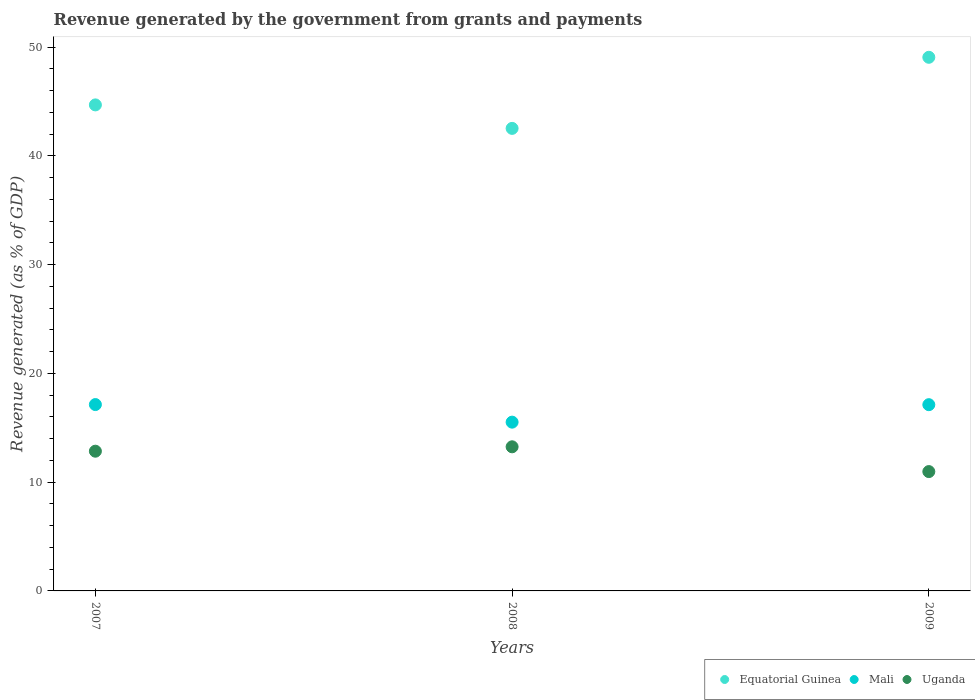What is the revenue generated by the government in Mali in 2007?
Offer a terse response. 17.14. Across all years, what is the maximum revenue generated by the government in Equatorial Guinea?
Provide a short and direct response. 49.07. Across all years, what is the minimum revenue generated by the government in Mali?
Give a very brief answer. 15.52. In which year was the revenue generated by the government in Uganda minimum?
Provide a short and direct response. 2009. What is the total revenue generated by the government in Mali in the graph?
Ensure brevity in your answer.  49.79. What is the difference between the revenue generated by the government in Mali in 2007 and that in 2008?
Your answer should be very brief. 1.62. What is the difference between the revenue generated by the government in Mali in 2009 and the revenue generated by the government in Equatorial Guinea in 2008?
Make the answer very short. -25.41. What is the average revenue generated by the government in Equatorial Guinea per year?
Keep it short and to the point. 45.44. In the year 2007, what is the difference between the revenue generated by the government in Uganda and revenue generated by the government in Equatorial Guinea?
Make the answer very short. -31.85. What is the ratio of the revenue generated by the government in Mali in 2007 to that in 2009?
Provide a succinct answer. 1. Is the difference between the revenue generated by the government in Uganda in 2008 and 2009 greater than the difference between the revenue generated by the government in Equatorial Guinea in 2008 and 2009?
Give a very brief answer. Yes. What is the difference between the highest and the second highest revenue generated by the government in Uganda?
Make the answer very short. 0.4. What is the difference between the highest and the lowest revenue generated by the government in Uganda?
Make the answer very short. 2.28. In how many years, is the revenue generated by the government in Equatorial Guinea greater than the average revenue generated by the government in Equatorial Guinea taken over all years?
Your answer should be very brief. 1. Is the sum of the revenue generated by the government in Uganda in 2008 and 2009 greater than the maximum revenue generated by the government in Mali across all years?
Make the answer very short. Yes. Is the revenue generated by the government in Mali strictly greater than the revenue generated by the government in Uganda over the years?
Your answer should be compact. Yes. How many dotlines are there?
Give a very brief answer. 3. Where does the legend appear in the graph?
Your answer should be very brief. Bottom right. How are the legend labels stacked?
Offer a terse response. Horizontal. What is the title of the graph?
Offer a terse response. Revenue generated by the government from grants and payments. What is the label or title of the X-axis?
Offer a terse response. Years. What is the label or title of the Y-axis?
Your answer should be compact. Revenue generated (as % of GDP). What is the Revenue generated (as % of GDP) of Equatorial Guinea in 2007?
Provide a short and direct response. 44.7. What is the Revenue generated (as % of GDP) in Mali in 2007?
Your response must be concise. 17.14. What is the Revenue generated (as % of GDP) of Uganda in 2007?
Give a very brief answer. 12.85. What is the Revenue generated (as % of GDP) in Equatorial Guinea in 2008?
Your response must be concise. 42.54. What is the Revenue generated (as % of GDP) of Mali in 2008?
Offer a very short reply. 15.52. What is the Revenue generated (as % of GDP) of Uganda in 2008?
Offer a very short reply. 13.25. What is the Revenue generated (as % of GDP) in Equatorial Guinea in 2009?
Offer a very short reply. 49.07. What is the Revenue generated (as % of GDP) of Mali in 2009?
Give a very brief answer. 17.13. What is the Revenue generated (as % of GDP) in Uganda in 2009?
Provide a short and direct response. 10.97. Across all years, what is the maximum Revenue generated (as % of GDP) of Equatorial Guinea?
Ensure brevity in your answer.  49.07. Across all years, what is the maximum Revenue generated (as % of GDP) in Mali?
Give a very brief answer. 17.14. Across all years, what is the maximum Revenue generated (as % of GDP) in Uganda?
Offer a very short reply. 13.25. Across all years, what is the minimum Revenue generated (as % of GDP) of Equatorial Guinea?
Your answer should be compact. 42.54. Across all years, what is the minimum Revenue generated (as % of GDP) of Mali?
Give a very brief answer. 15.52. Across all years, what is the minimum Revenue generated (as % of GDP) of Uganda?
Give a very brief answer. 10.97. What is the total Revenue generated (as % of GDP) in Equatorial Guinea in the graph?
Your response must be concise. 136.31. What is the total Revenue generated (as % of GDP) in Mali in the graph?
Your answer should be very brief. 49.79. What is the total Revenue generated (as % of GDP) in Uganda in the graph?
Your response must be concise. 37.08. What is the difference between the Revenue generated (as % of GDP) of Equatorial Guinea in 2007 and that in 2008?
Make the answer very short. 2.16. What is the difference between the Revenue generated (as % of GDP) in Mali in 2007 and that in 2008?
Make the answer very short. 1.62. What is the difference between the Revenue generated (as % of GDP) in Uganda in 2007 and that in 2008?
Ensure brevity in your answer.  -0.4. What is the difference between the Revenue generated (as % of GDP) in Equatorial Guinea in 2007 and that in 2009?
Offer a terse response. -4.38. What is the difference between the Revenue generated (as % of GDP) in Mali in 2007 and that in 2009?
Your response must be concise. 0.01. What is the difference between the Revenue generated (as % of GDP) of Uganda in 2007 and that in 2009?
Your answer should be very brief. 1.88. What is the difference between the Revenue generated (as % of GDP) of Equatorial Guinea in 2008 and that in 2009?
Offer a very short reply. -6.54. What is the difference between the Revenue generated (as % of GDP) in Mali in 2008 and that in 2009?
Your response must be concise. -1.61. What is the difference between the Revenue generated (as % of GDP) of Uganda in 2008 and that in 2009?
Provide a succinct answer. 2.28. What is the difference between the Revenue generated (as % of GDP) of Equatorial Guinea in 2007 and the Revenue generated (as % of GDP) of Mali in 2008?
Offer a terse response. 29.18. What is the difference between the Revenue generated (as % of GDP) of Equatorial Guinea in 2007 and the Revenue generated (as % of GDP) of Uganda in 2008?
Make the answer very short. 31.44. What is the difference between the Revenue generated (as % of GDP) in Mali in 2007 and the Revenue generated (as % of GDP) in Uganda in 2008?
Ensure brevity in your answer.  3.88. What is the difference between the Revenue generated (as % of GDP) of Equatorial Guinea in 2007 and the Revenue generated (as % of GDP) of Mali in 2009?
Your answer should be very brief. 27.57. What is the difference between the Revenue generated (as % of GDP) of Equatorial Guinea in 2007 and the Revenue generated (as % of GDP) of Uganda in 2009?
Give a very brief answer. 33.72. What is the difference between the Revenue generated (as % of GDP) of Mali in 2007 and the Revenue generated (as % of GDP) of Uganda in 2009?
Make the answer very short. 6.16. What is the difference between the Revenue generated (as % of GDP) in Equatorial Guinea in 2008 and the Revenue generated (as % of GDP) in Mali in 2009?
Ensure brevity in your answer.  25.41. What is the difference between the Revenue generated (as % of GDP) of Equatorial Guinea in 2008 and the Revenue generated (as % of GDP) of Uganda in 2009?
Give a very brief answer. 31.56. What is the difference between the Revenue generated (as % of GDP) in Mali in 2008 and the Revenue generated (as % of GDP) in Uganda in 2009?
Your answer should be compact. 4.55. What is the average Revenue generated (as % of GDP) of Equatorial Guinea per year?
Your answer should be compact. 45.44. What is the average Revenue generated (as % of GDP) of Mali per year?
Make the answer very short. 16.6. What is the average Revenue generated (as % of GDP) in Uganda per year?
Provide a short and direct response. 12.36. In the year 2007, what is the difference between the Revenue generated (as % of GDP) in Equatorial Guinea and Revenue generated (as % of GDP) in Mali?
Your response must be concise. 27.56. In the year 2007, what is the difference between the Revenue generated (as % of GDP) of Equatorial Guinea and Revenue generated (as % of GDP) of Uganda?
Your answer should be very brief. 31.85. In the year 2007, what is the difference between the Revenue generated (as % of GDP) in Mali and Revenue generated (as % of GDP) in Uganda?
Ensure brevity in your answer.  4.29. In the year 2008, what is the difference between the Revenue generated (as % of GDP) of Equatorial Guinea and Revenue generated (as % of GDP) of Mali?
Offer a very short reply. 27.02. In the year 2008, what is the difference between the Revenue generated (as % of GDP) in Equatorial Guinea and Revenue generated (as % of GDP) in Uganda?
Provide a succinct answer. 29.28. In the year 2008, what is the difference between the Revenue generated (as % of GDP) of Mali and Revenue generated (as % of GDP) of Uganda?
Make the answer very short. 2.27. In the year 2009, what is the difference between the Revenue generated (as % of GDP) of Equatorial Guinea and Revenue generated (as % of GDP) of Mali?
Provide a succinct answer. 31.95. In the year 2009, what is the difference between the Revenue generated (as % of GDP) in Equatorial Guinea and Revenue generated (as % of GDP) in Uganda?
Keep it short and to the point. 38.1. In the year 2009, what is the difference between the Revenue generated (as % of GDP) in Mali and Revenue generated (as % of GDP) in Uganda?
Make the answer very short. 6.15. What is the ratio of the Revenue generated (as % of GDP) in Equatorial Guinea in 2007 to that in 2008?
Ensure brevity in your answer.  1.05. What is the ratio of the Revenue generated (as % of GDP) of Mali in 2007 to that in 2008?
Your answer should be very brief. 1.1. What is the ratio of the Revenue generated (as % of GDP) of Uganda in 2007 to that in 2008?
Offer a very short reply. 0.97. What is the ratio of the Revenue generated (as % of GDP) in Equatorial Guinea in 2007 to that in 2009?
Your response must be concise. 0.91. What is the ratio of the Revenue generated (as % of GDP) of Uganda in 2007 to that in 2009?
Your answer should be very brief. 1.17. What is the ratio of the Revenue generated (as % of GDP) of Equatorial Guinea in 2008 to that in 2009?
Your answer should be compact. 0.87. What is the ratio of the Revenue generated (as % of GDP) of Mali in 2008 to that in 2009?
Offer a terse response. 0.91. What is the ratio of the Revenue generated (as % of GDP) in Uganda in 2008 to that in 2009?
Your answer should be compact. 1.21. What is the difference between the highest and the second highest Revenue generated (as % of GDP) in Equatorial Guinea?
Keep it short and to the point. 4.38. What is the difference between the highest and the second highest Revenue generated (as % of GDP) of Mali?
Your answer should be compact. 0.01. What is the difference between the highest and the second highest Revenue generated (as % of GDP) of Uganda?
Your answer should be compact. 0.4. What is the difference between the highest and the lowest Revenue generated (as % of GDP) of Equatorial Guinea?
Provide a succinct answer. 6.54. What is the difference between the highest and the lowest Revenue generated (as % of GDP) of Mali?
Your answer should be compact. 1.62. What is the difference between the highest and the lowest Revenue generated (as % of GDP) in Uganda?
Keep it short and to the point. 2.28. 